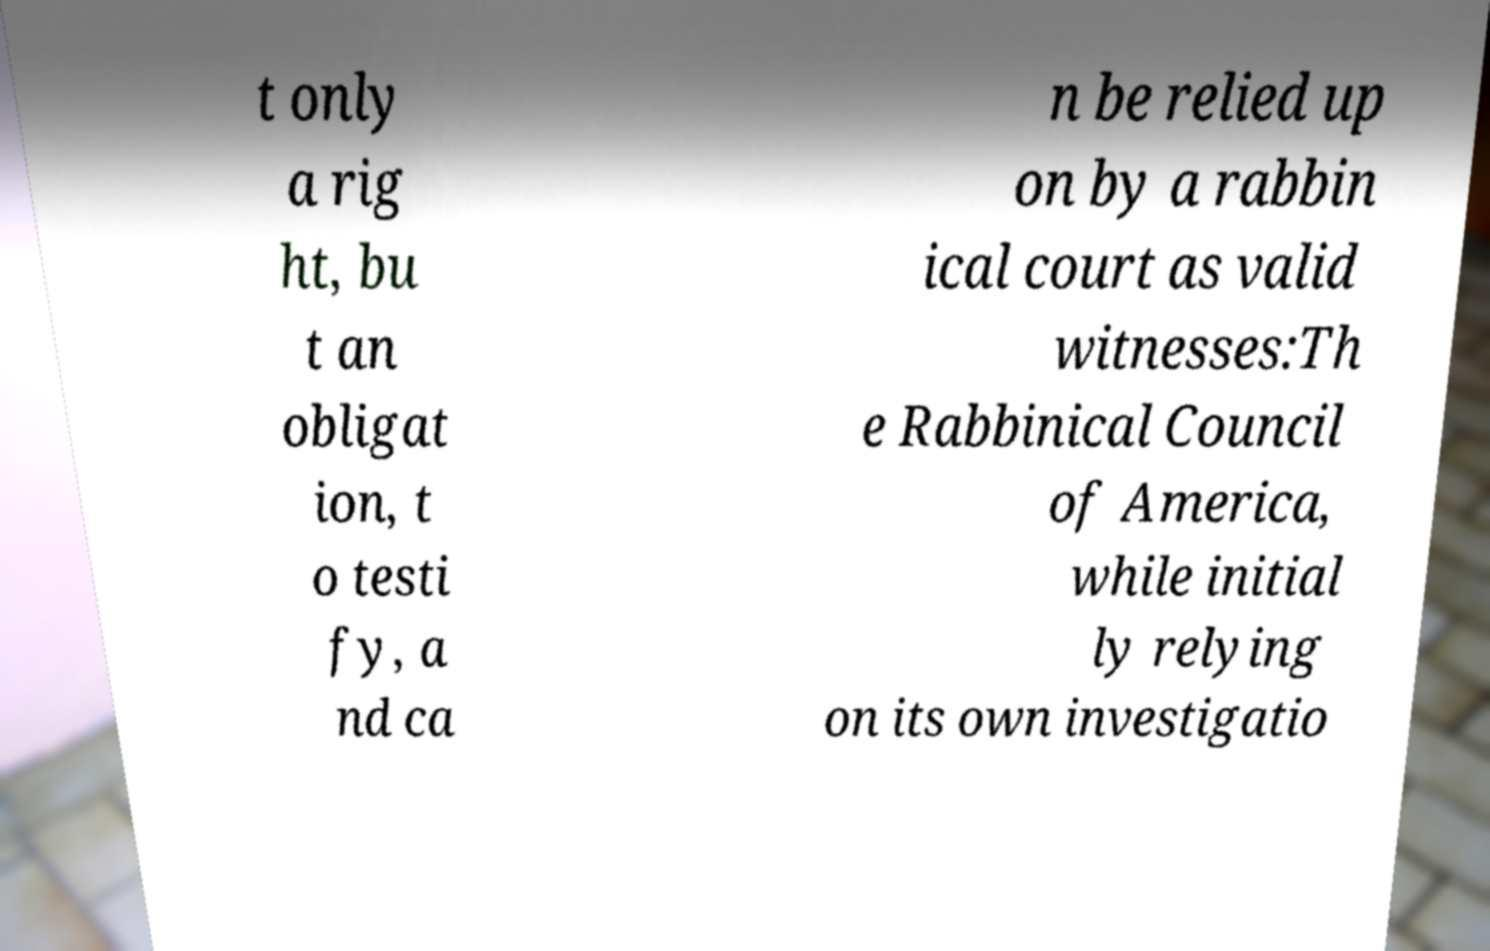I need the written content from this picture converted into text. Can you do that? t only a rig ht, bu t an obligat ion, t o testi fy, a nd ca n be relied up on by a rabbin ical court as valid witnesses:Th e Rabbinical Council of America, while initial ly relying on its own investigatio 